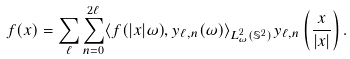Convert formula to latex. <formula><loc_0><loc_0><loc_500><loc_500>f ( x ) = \sum _ { \ell } \sum _ { n = 0 } ^ { 2 \ell } \langle f ( | x | \omega ) , y _ { \ell , n } ( \omega ) \rangle _ { L ^ { 2 } _ { \omega } ( \mathbb { S } ^ { 2 } ) } y _ { \ell , n } \left ( \frac { x } { | x | } \right ) .</formula> 